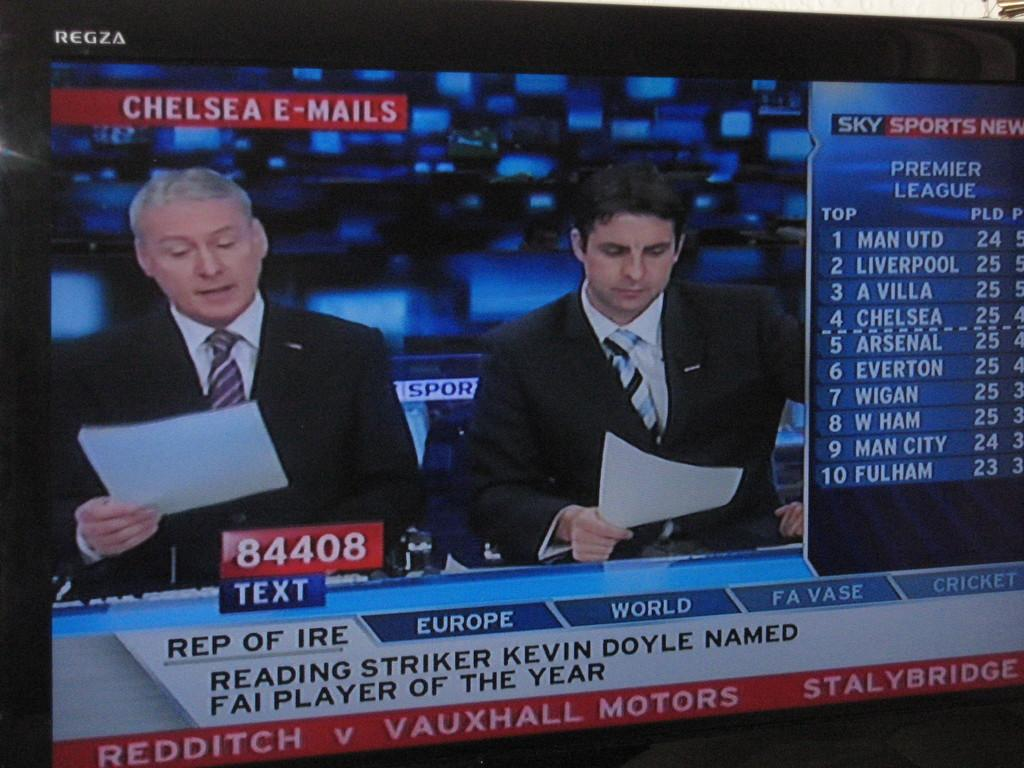<image>
Describe the image concisely. Broadcasters on Sky network read emails about Kevin Doyle being named FAI Player of the Year. 